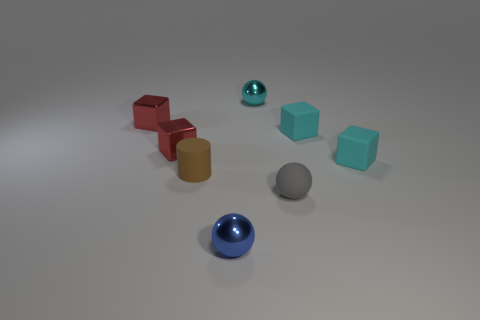Is there a pattern to how the objects are arranged? The objects are arranged without a clear pattern, scattered across the surface in a random manner. This lack of pattern adds an element of unpredictability and visual interest to the scene. 